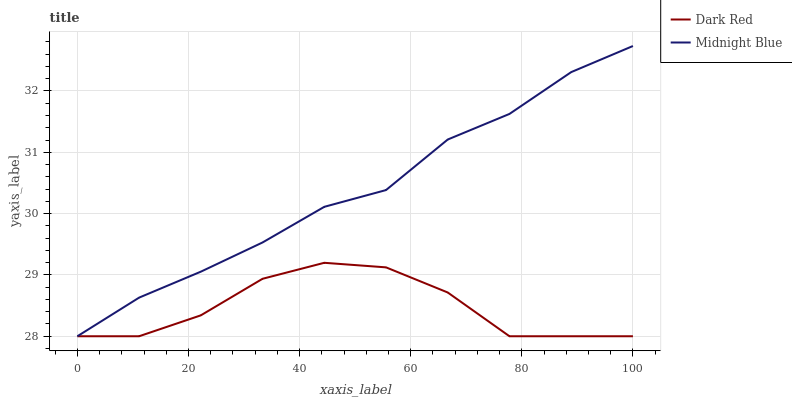Does Dark Red have the minimum area under the curve?
Answer yes or no. Yes. Does Midnight Blue have the maximum area under the curve?
Answer yes or no. Yes. Does Midnight Blue have the minimum area under the curve?
Answer yes or no. No. Is Midnight Blue the smoothest?
Answer yes or no. Yes. Is Dark Red the roughest?
Answer yes or no. Yes. Is Midnight Blue the roughest?
Answer yes or no. No. Does Dark Red have the lowest value?
Answer yes or no. Yes. Does Midnight Blue have the highest value?
Answer yes or no. Yes. Does Dark Red intersect Midnight Blue?
Answer yes or no. Yes. Is Dark Red less than Midnight Blue?
Answer yes or no. No. Is Dark Red greater than Midnight Blue?
Answer yes or no. No. 